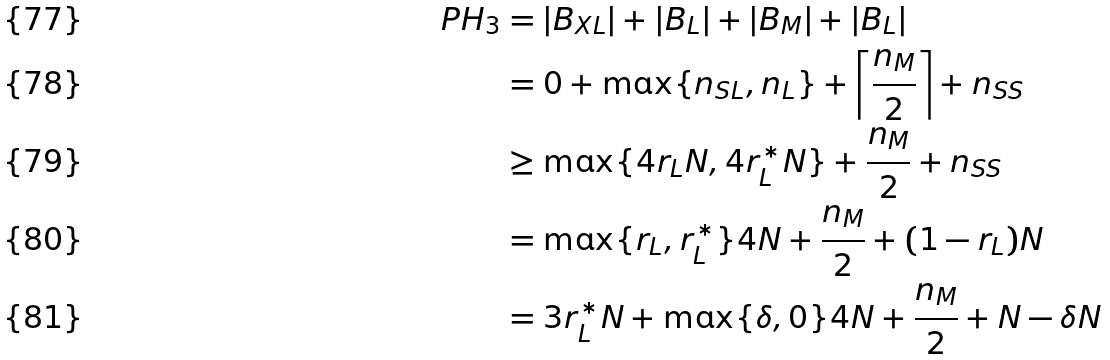<formula> <loc_0><loc_0><loc_500><loc_500>P H _ { 3 } & = | B _ { X L } | + | B _ { L } | + | B _ { M } | + | B _ { L } | \\ & = 0 + \max \{ n _ { S L } , n _ { L } \} + \left \lceil \frac { n _ { M } } { 2 } \right \rceil + n _ { S S } \\ & \geq \max \{ 4 r _ { L } N , 4 r _ { L } ^ { * } N \} + \frac { n _ { M } } { 2 } + n _ { S S } \\ & = \max \{ r _ { L } , r _ { L } ^ { * } \} 4 N + \frac { n _ { M } } { 2 } + ( 1 - r _ { L } ) N \\ & = 3 r _ { L } ^ { * } N + \max \{ \delta , 0 \} 4 N + \frac { n _ { M } } { 2 } + N - \delta N</formula> 